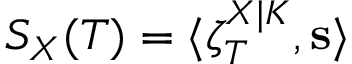Convert formula to latex. <formula><loc_0><loc_0><loc_500><loc_500>S _ { X } ( T ) = \langle \zeta _ { T } ^ { X | K } , s \rangle</formula> 